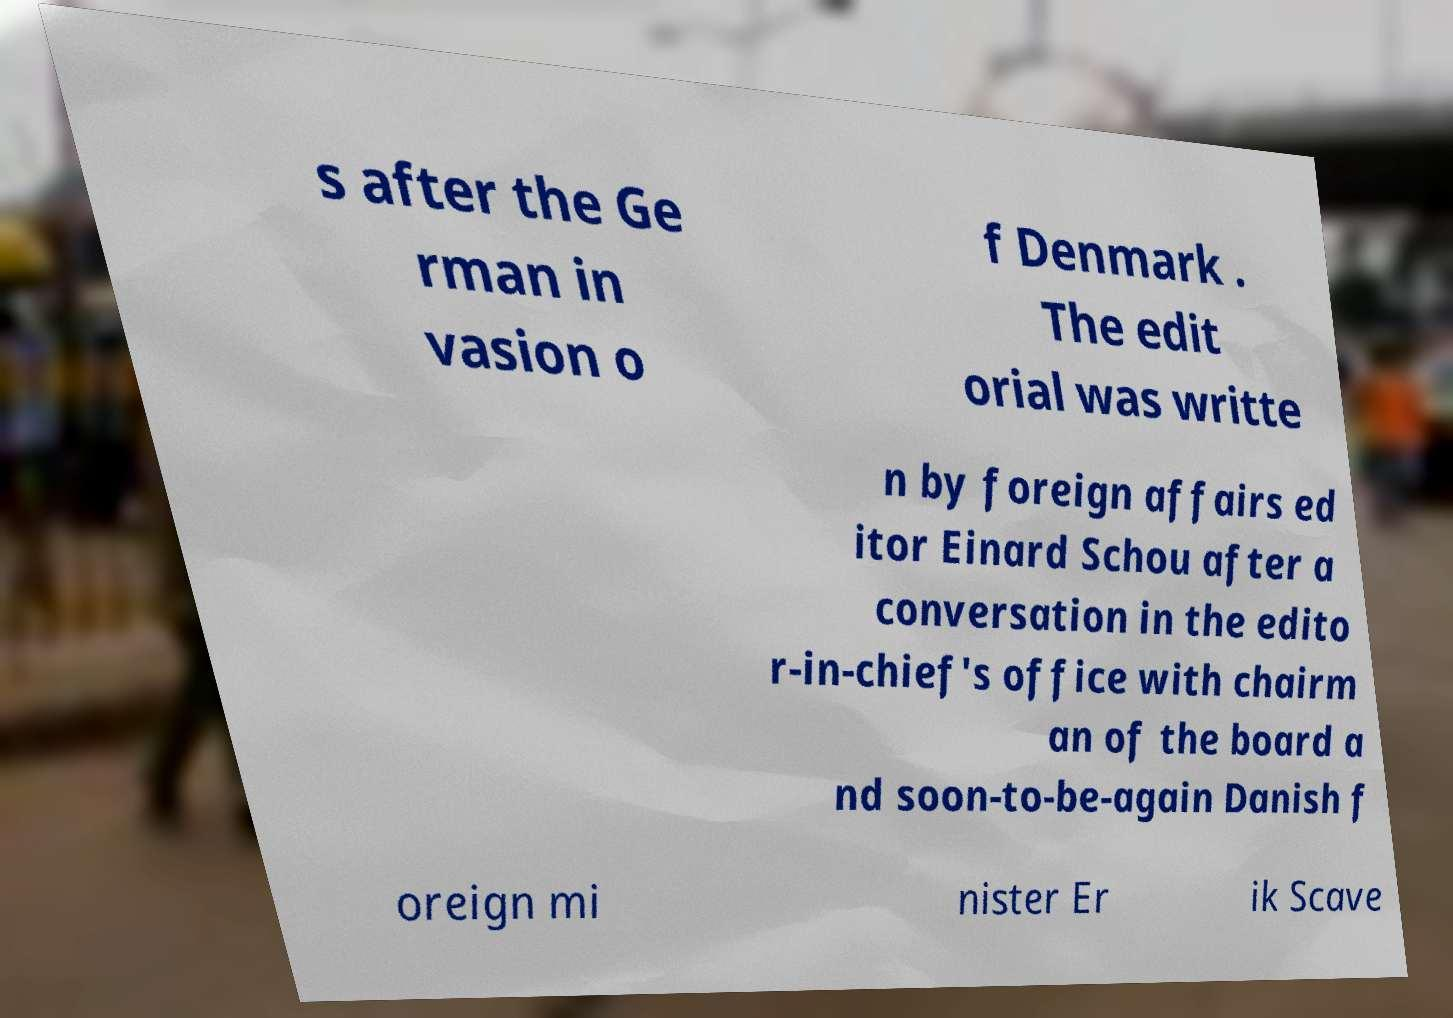For documentation purposes, I need the text within this image transcribed. Could you provide that? s after the Ge rman in vasion o f Denmark . The edit orial was writte n by foreign affairs ed itor Einard Schou after a conversation in the edito r-in-chief's office with chairm an of the board a nd soon-to-be-again Danish f oreign mi nister Er ik Scave 